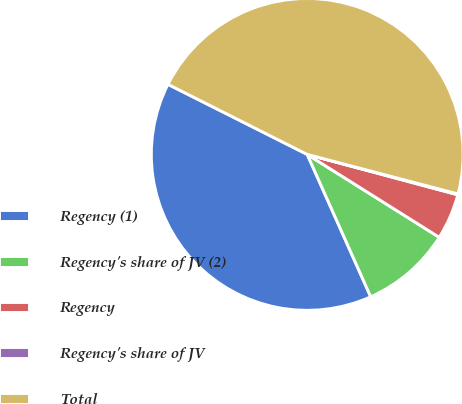Convert chart. <chart><loc_0><loc_0><loc_500><loc_500><pie_chart><fcel>Regency (1)<fcel>Regency's share of JV (2)<fcel>Regency<fcel>Regency's share of JV<fcel>Total<nl><fcel>39.1%<fcel>9.4%<fcel>4.75%<fcel>0.09%<fcel>46.66%<nl></chart> 